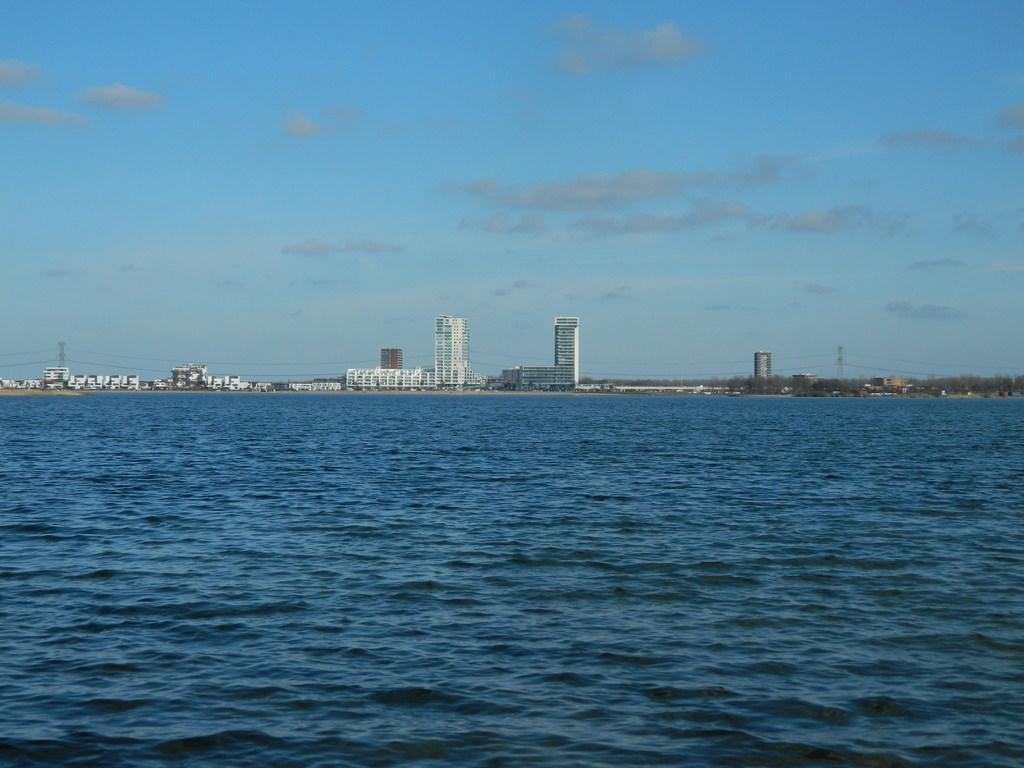How would you summarize this image in a sentence or two? In this image, we can see a water in an ocean. In the background, we can see some buildings, houses, trees, electric pole, electric wires. At the top, we can see a sky which is cloudy. 